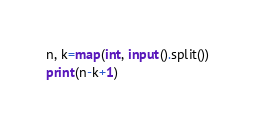<code> <loc_0><loc_0><loc_500><loc_500><_Python_>n, k=map(int, input().split())
print(n-k+1)</code> 